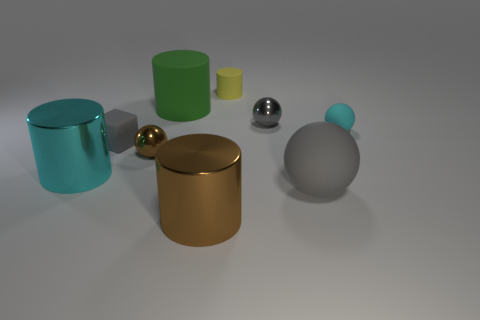Subtract all cyan spheres. How many spheres are left? 3 Add 1 yellow things. How many objects exist? 10 Subtract all cyan spheres. How many spheres are left? 3 Subtract all big matte objects. Subtract all small gray matte objects. How many objects are left? 6 Add 6 cyan cylinders. How many cyan cylinders are left? 7 Add 2 cyan metal objects. How many cyan metal objects exist? 3 Subtract 2 gray spheres. How many objects are left? 7 Subtract all spheres. How many objects are left? 5 Subtract 1 cubes. How many cubes are left? 0 Subtract all gray balls. Subtract all red cylinders. How many balls are left? 2 